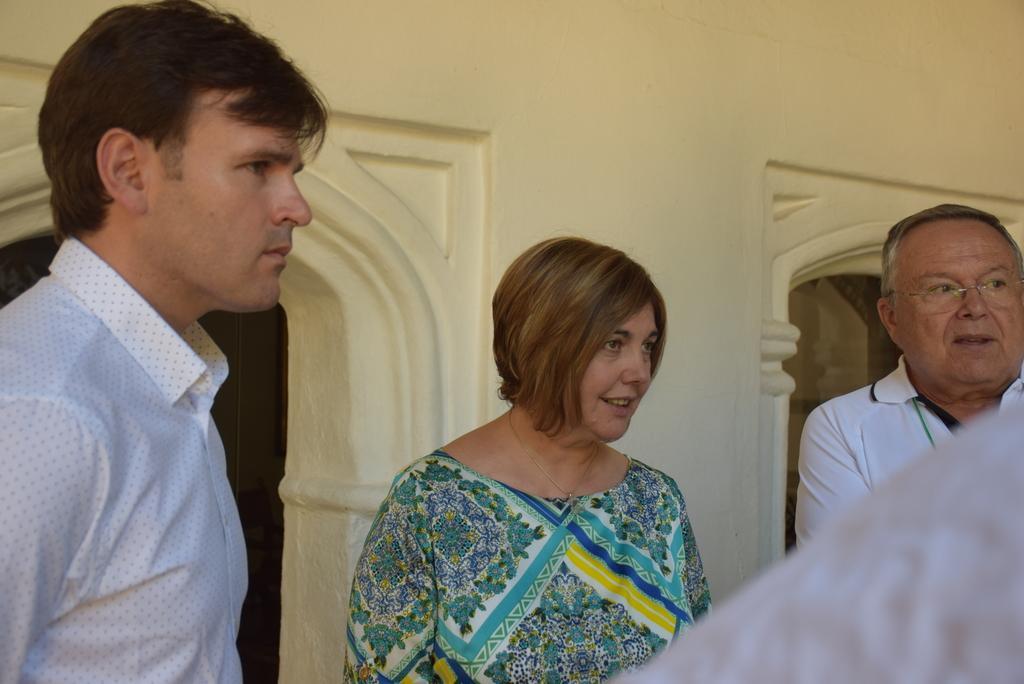Describe this image in one or two sentences. In this image, we can see three people. They are looking at the right side. Here a person is wearing glasses. Background i can see a wall, door, glass. In the middle of the image, we can see a woman is smiling. 